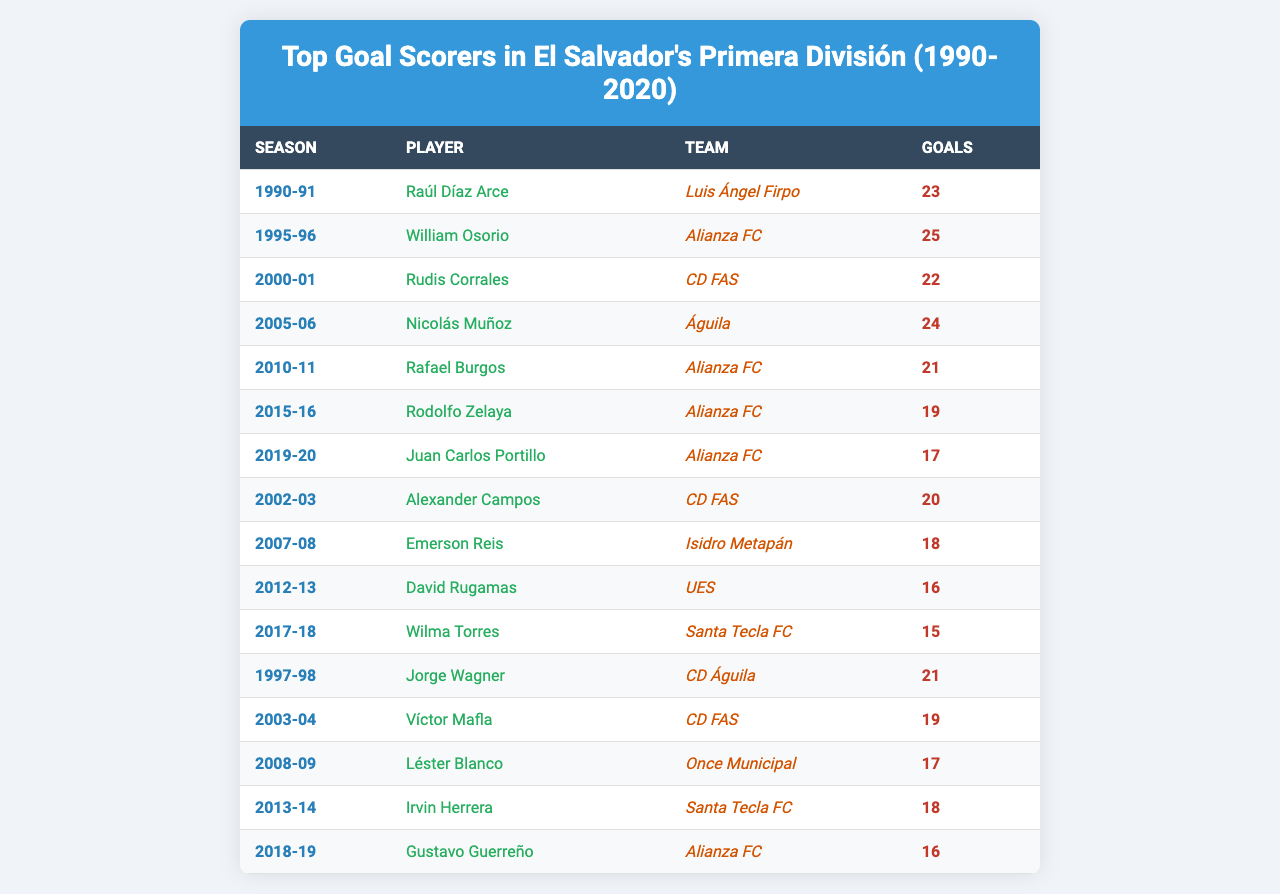What was the highest number of goals scored in a single season? The table shows that William Osorio scored the highest number of goals with 25 goals in the 1995-96 season.
Answer: 25 Who was the top scorer for the 2005-06 season? In the 2005-06 season, Nicolás Muñoz was the top scorer with 24 goals for Águila.
Answer: Nicolás Muñoz How many goals did the top scorers in the 1990-91 and 1997-98 seasons score combined? In the 1990-91 season, Raúl Díaz Arce scored 23 goals, and in the 1997-98 season, Jorge Wagner scored 21 goals. The combined total is 23 + 21 = 44.
Answer: 44 Which player scored 19 goals for Alianza FC in the 2015-16 season? Rodolfo Zelaya scored 19 goals for Alianza FC in the 2015-16 season.
Answer: Rodolfo Zelaya Is the top scorer from Alianza FC more than once in the table? Yes, Alianza FC has multiple top scorers in different seasons: Rafael Burgos in the 2010-11 season and Rodolfo Zelaya in the 2015-16 season.
Answer: Yes What is the average number of goals scored by the top scorers from the years 2010-11 to 2019-20? The number of goals scored by the top scorers from 2010-11 (21), 2015-16 (19), and 2019-20 (17) is 21, 19, and 17 respectively; summing these gives 21+19+17=57. There are 3 seasons, so the average is 57 / 3 = 19.
Answer: 19 In how many seasons did a player score 22 goals? There were two seasons where players scored 22 goals: Rudis Corrales in 2000-01 and Raúl Díaz Arce in 1990-91.
Answer: 2 Which team had the highest scoring player in the seasons listed? Alianza FC had William Osorio as the highest scoring player with 25 goals in the 1995-96 season.
Answer: Alianza FC How many players scored 18 goals or more from 2000 to 2020? From the data, the players who scored 18 or more goals are Nicolás Muñoz (24), Rudis Corrales (22), Raúl Díaz Arce (23), William Osorio (25), and others; a total of 8 players scored 18 goals or more in those seasons.
Answer: 8 Was the number of goals scored by the top scorer in 2018-19 higher than that in 2017-18? No, in 2018-19, Gustavo Guerreño scored 16 goals, which is less than Wilma Torres' 15 goals from 2017-18.
Answer: No 